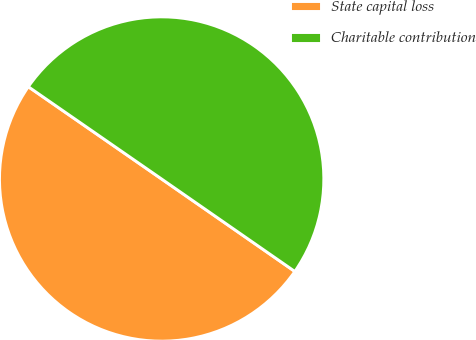<chart> <loc_0><loc_0><loc_500><loc_500><pie_chart><fcel>State capital loss<fcel>Charitable contribution<nl><fcel>49.98%<fcel>50.02%<nl></chart> 